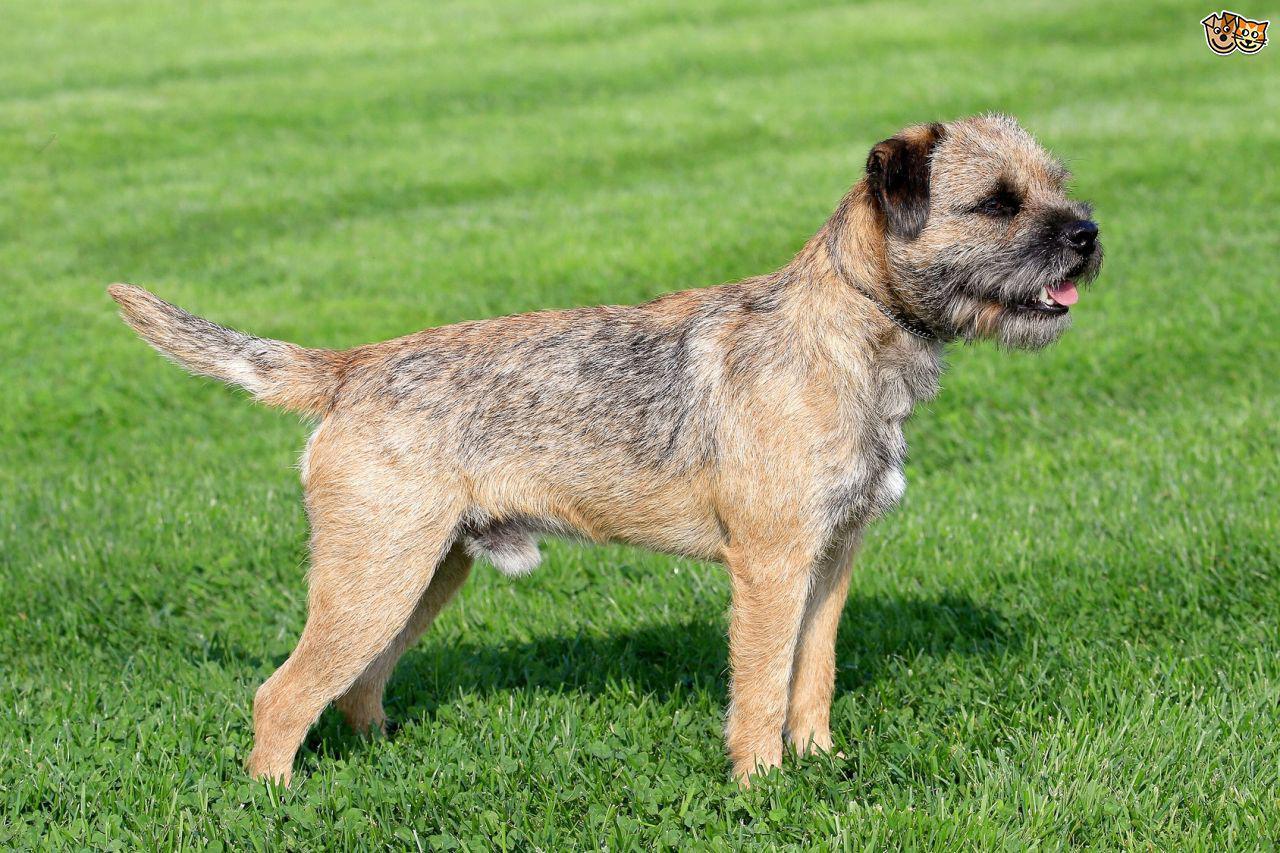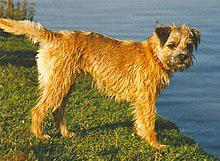The first image is the image on the left, the second image is the image on the right. Given the left and right images, does the statement "The right image has exactly one dog who's body is facing towards the left." hold true? Answer yes or no. No. The first image is the image on the left, the second image is the image on the right. Evaluate the accuracy of this statement regarding the images: "Both dogs are facing the same direction.". Is it true? Answer yes or no. Yes. The first image is the image on the left, the second image is the image on the right. Assess this claim about the two images: "The animal in the image on the left is not looking toward the camera.". Correct or not? Answer yes or no. Yes. 